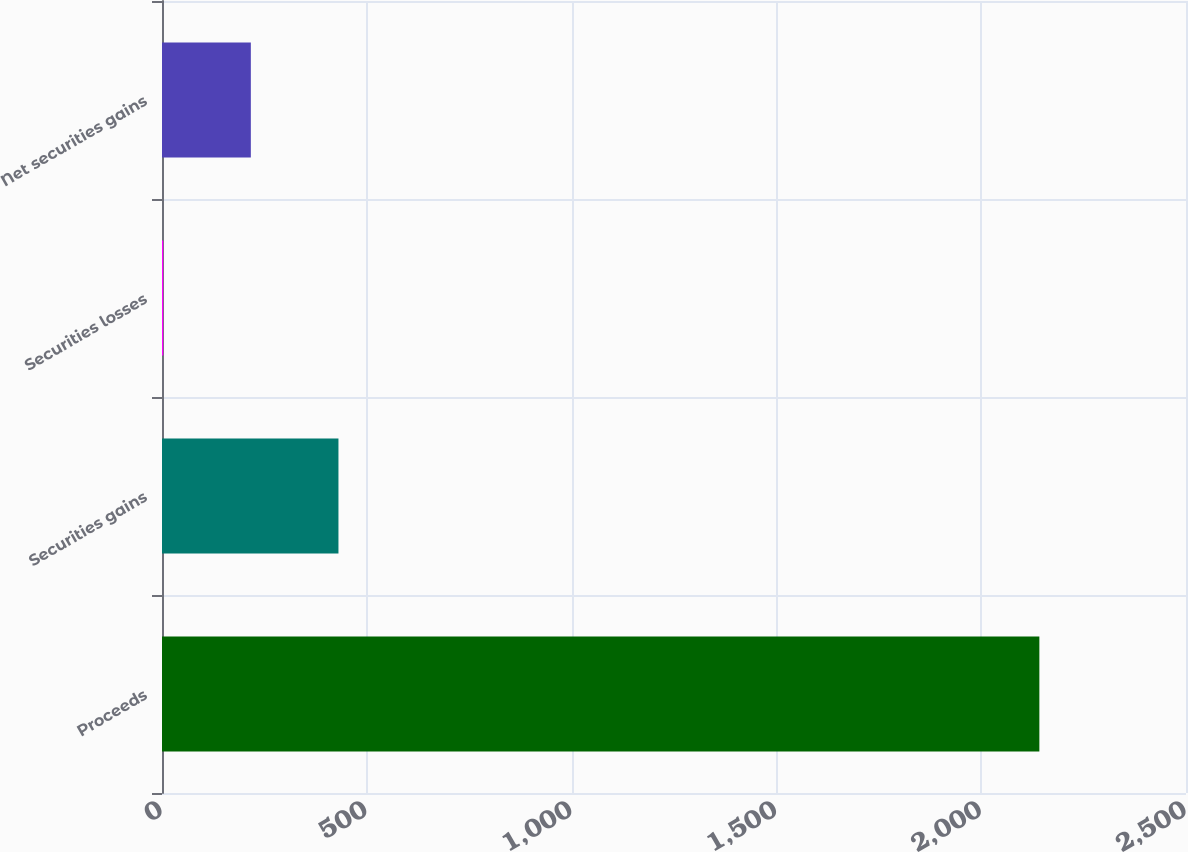<chart> <loc_0><loc_0><loc_500><loc_500><bar_chart><fcel>Proceeds<fcel>Securities gains<fcel>Securities losses<fcel>Net securities gains<nl><fcel>2142<fcel>430.8<fcel>3<fcel>216.9<nl></chart> 